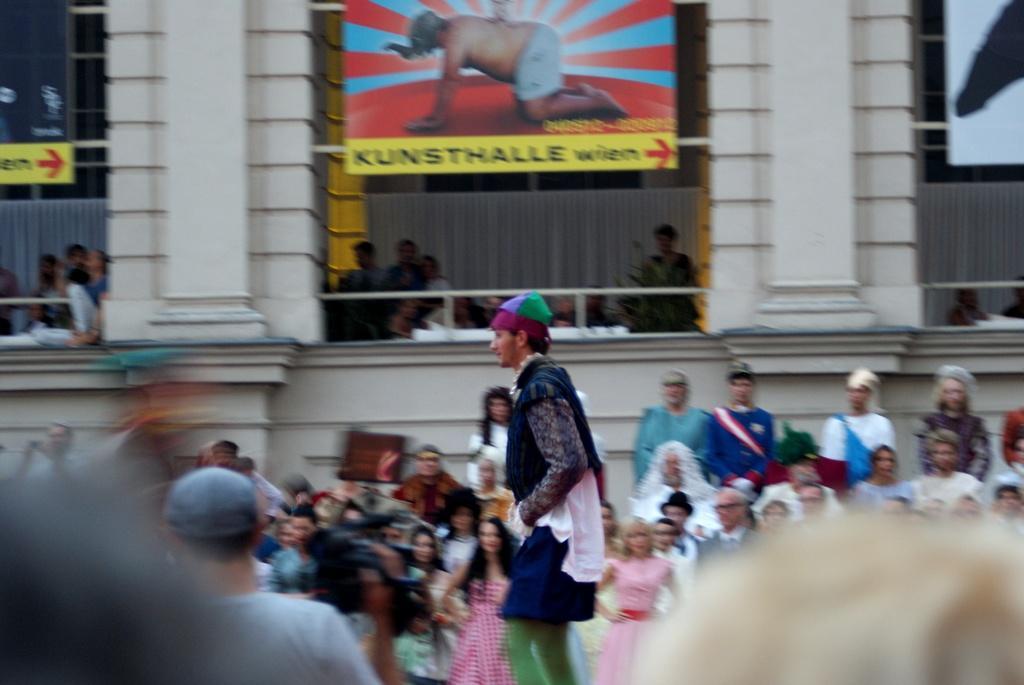How would you summarize this image in a sentence or two? In this image there are a group of persons standing, there is a man holding a video camera, he is wearing a cap, there are pillars towards the top of the image, there are curtains, there is a wall behind the persons, there are boards towards the top of the image, there is text on the boards. 